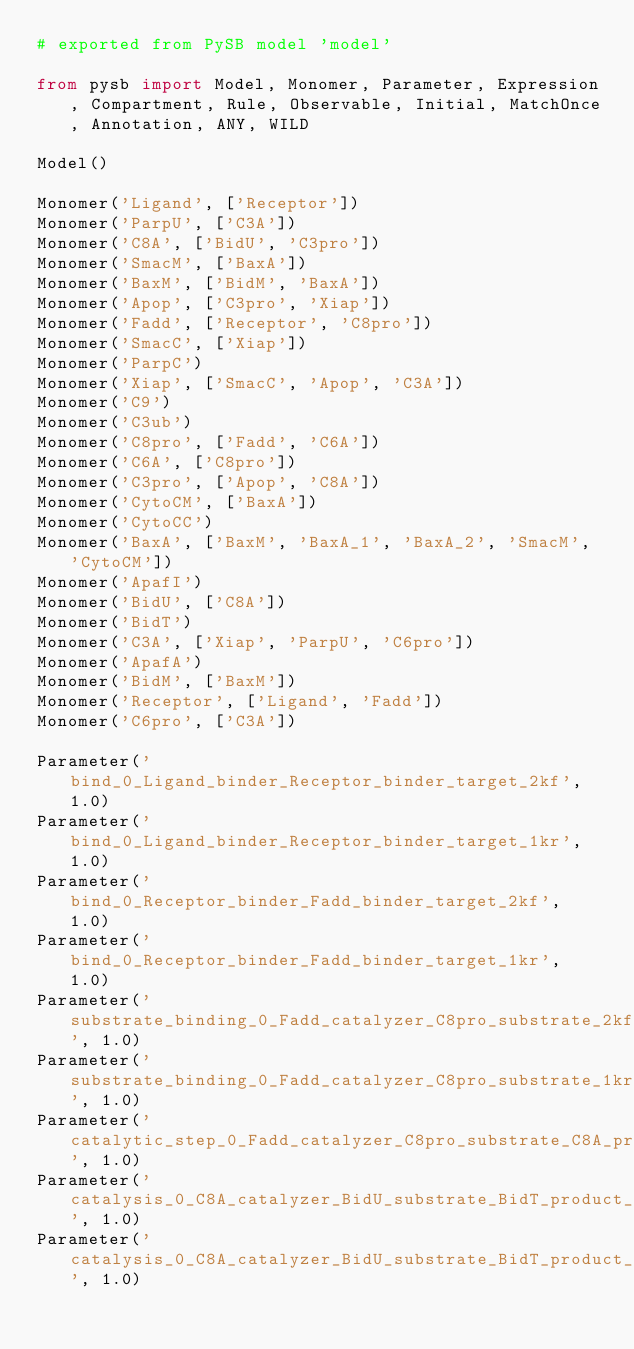Convert code to text. <code><loc_0><loc_0><loc_500><loc_500><_Python_># exported from PySB model 'model'

from pysb import Model, Monomer, Parameter, Expression, Compartment, Rule, Observable, Initial, MatchOnce, Annotation, ANY, WILD

Model()

Monomer('Ligand', ['Receptor'])
Monomer('ParpU', ['C3A'])
Monomer('C8A', ['BidU', 'C3pro'])
Monomer('SmacM', ['BaxA'])
Monomer('BaxM', ['BidM', 'BaxA'])
Monomer('Apop', ['C3pro', 'Xiap'])
Monomer('Fadd', ['Receptor', 'C8pro'])
Monomer('SmacC', ['Xiap'])
Monomer('ParpC')
Monomer('Xiap', ['SmacC', 'Apop', 'C3A'])
Monomer('C9')
Monomer('C3ub')
Monomer('C8pro', ['Fadd', 'C6A'])
Monomer('C6A', ['C8pro'])
Monomer('C3pro', ['Apop', 'C8A'])
Monomer('CytoCM', ['BaxA'])
Monomer('CytoCC')
Monomer('BaxA', ['BaxM', 'BaxA_1', 'BaxA_2', 'SmacM', 'CytoCM'])
Monomer('ApafI')
Monomer('BidU', ['C8A'])
Monomer('BidT')
Monomer('C3A', ['Xiap', 'ParpU', 'C6pro'])
Monomer('ApafA')
Monomer('BidM', ['BaxM'])
Monomer('Receptor', ['Ligand', 'Fadd'])
Monomer('C6pro', ['C3A'])

Parameter('bind_0_Ligand_binder_Receptor_binder_target_2kf', 1.0)
Parameter('bind_0_Ligand_binder_Receptor_binder_target_1kr', 1.0)
Parameter('bind_0_Receptor_binder_Fadd_binder_target_2kf', 1.0)
Parameter('bind_0_Receptor_binder_Fadd_binder_target_1kr', 1.0)
Parameter('substrate_binding_0_Fadd_catalyzer_C8pro_substrate_2kf', 1.0)
Parameter('substrate_binding_0_Fadd_catalyzer_C8pro_substrate_1kr', 1.0)
Parameter('catalytic_step_0_Fadd_catalyzer_C8pro_substrate_C8A_product_1kc', 1.0)
Parameter('catalysis_0_C8A_catalyzer_BidU_substrate_BidT_product_2kf', 1.0)
Parameter('catalysis_0_C8A_catalyzer_BidU_substrate_BidT_product_1kr', 1.0)</code> 